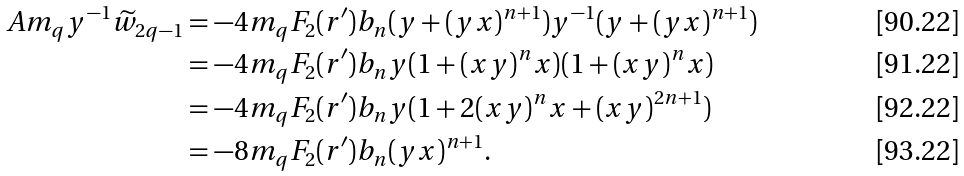Convert formula to latex. <formula><loc_0><loc_0><loc_500><loc_500>A m _ { q } y ^ { - 1 } \widetilde { w } _ { 2 q - 1 } & = - 4 m _ { q } F _ { 2 } ( r ^ { \prime } ) b _ { n } ( y + ( y x ) ^ { n + 1 } ) y ^ { - 1 } ( y + ( y x ) ^ { n + 1 } ) \\ & = - 4 m _ { q } F _ { 2 } ( r ^ { \prime } ) b _ { n } y ( 1 + ( x y ) ^ { n } x ) ( 1 + ( x y ) ^ { n } x ) \\ & = - 4 m _ { q } F _ { 2 } ( r ^ { \prime } ) b _ { n } y ( 1 + 2 ( x y ) ^ { n } x + ( x y ) ^ { 2 n + 1 } ) \\ & = - 8 m _ { q } F _ { 2 } ( r ^ { \prime } ) b _ { n } ( y x ) ^ { n + 1 } .</formula> 